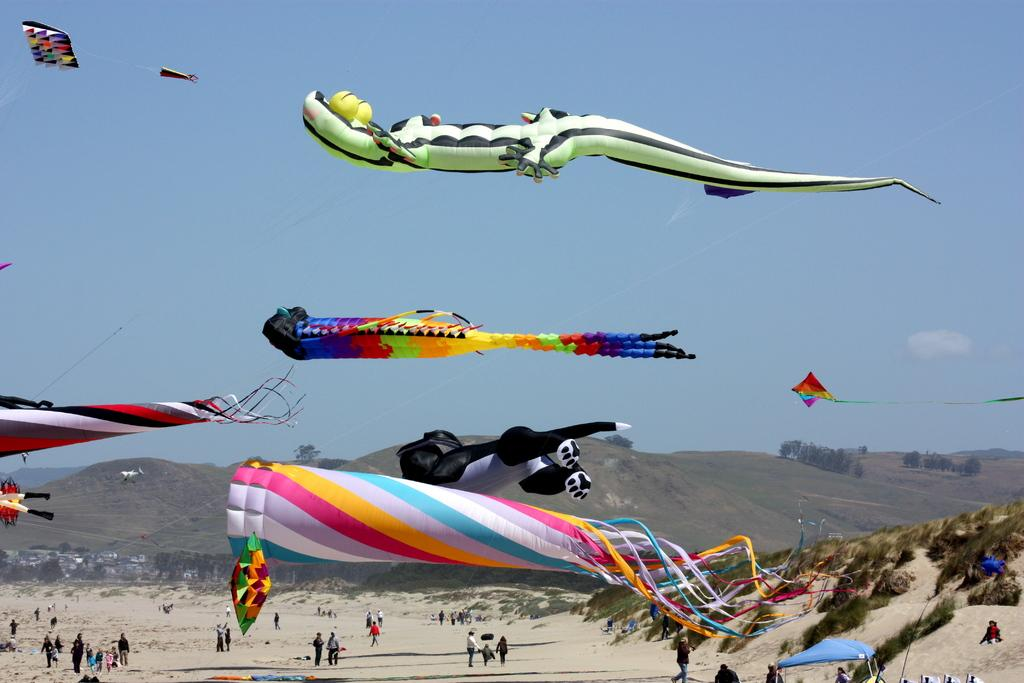What is the main subject of the image? The main subject of the image is kites. Can you describe the people in the image? There is a group of people in the image. What can be seen in the background of the image? There are hills, trees, and clouds in the background of the image. What type of salt is being used to flavor the kites in the image? There is no salt present in the image, as kites are not a food item and therefore do not require seasoning. 